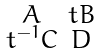Convert formula to latex. <formula><loc_0><loc_0><loc_500><loc_500>\begin{smallmatrix} A & t B \\ t ^ { - 1 } C & D \end{smallmatrix}</formula> 